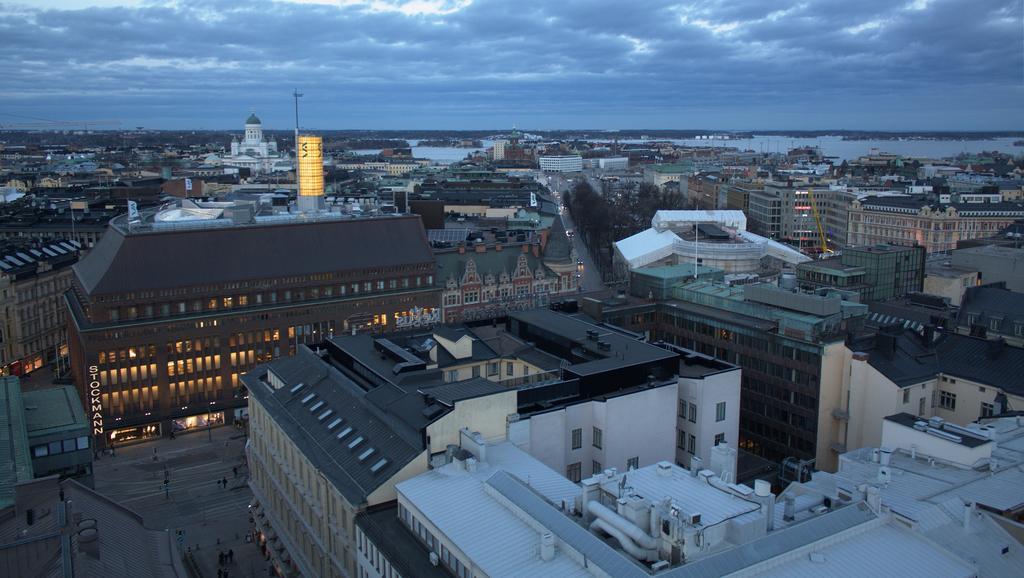Please provide a concise description of this image. It is the top view of a city, it has many huge buildings and houses and there is a water surface in the background. 